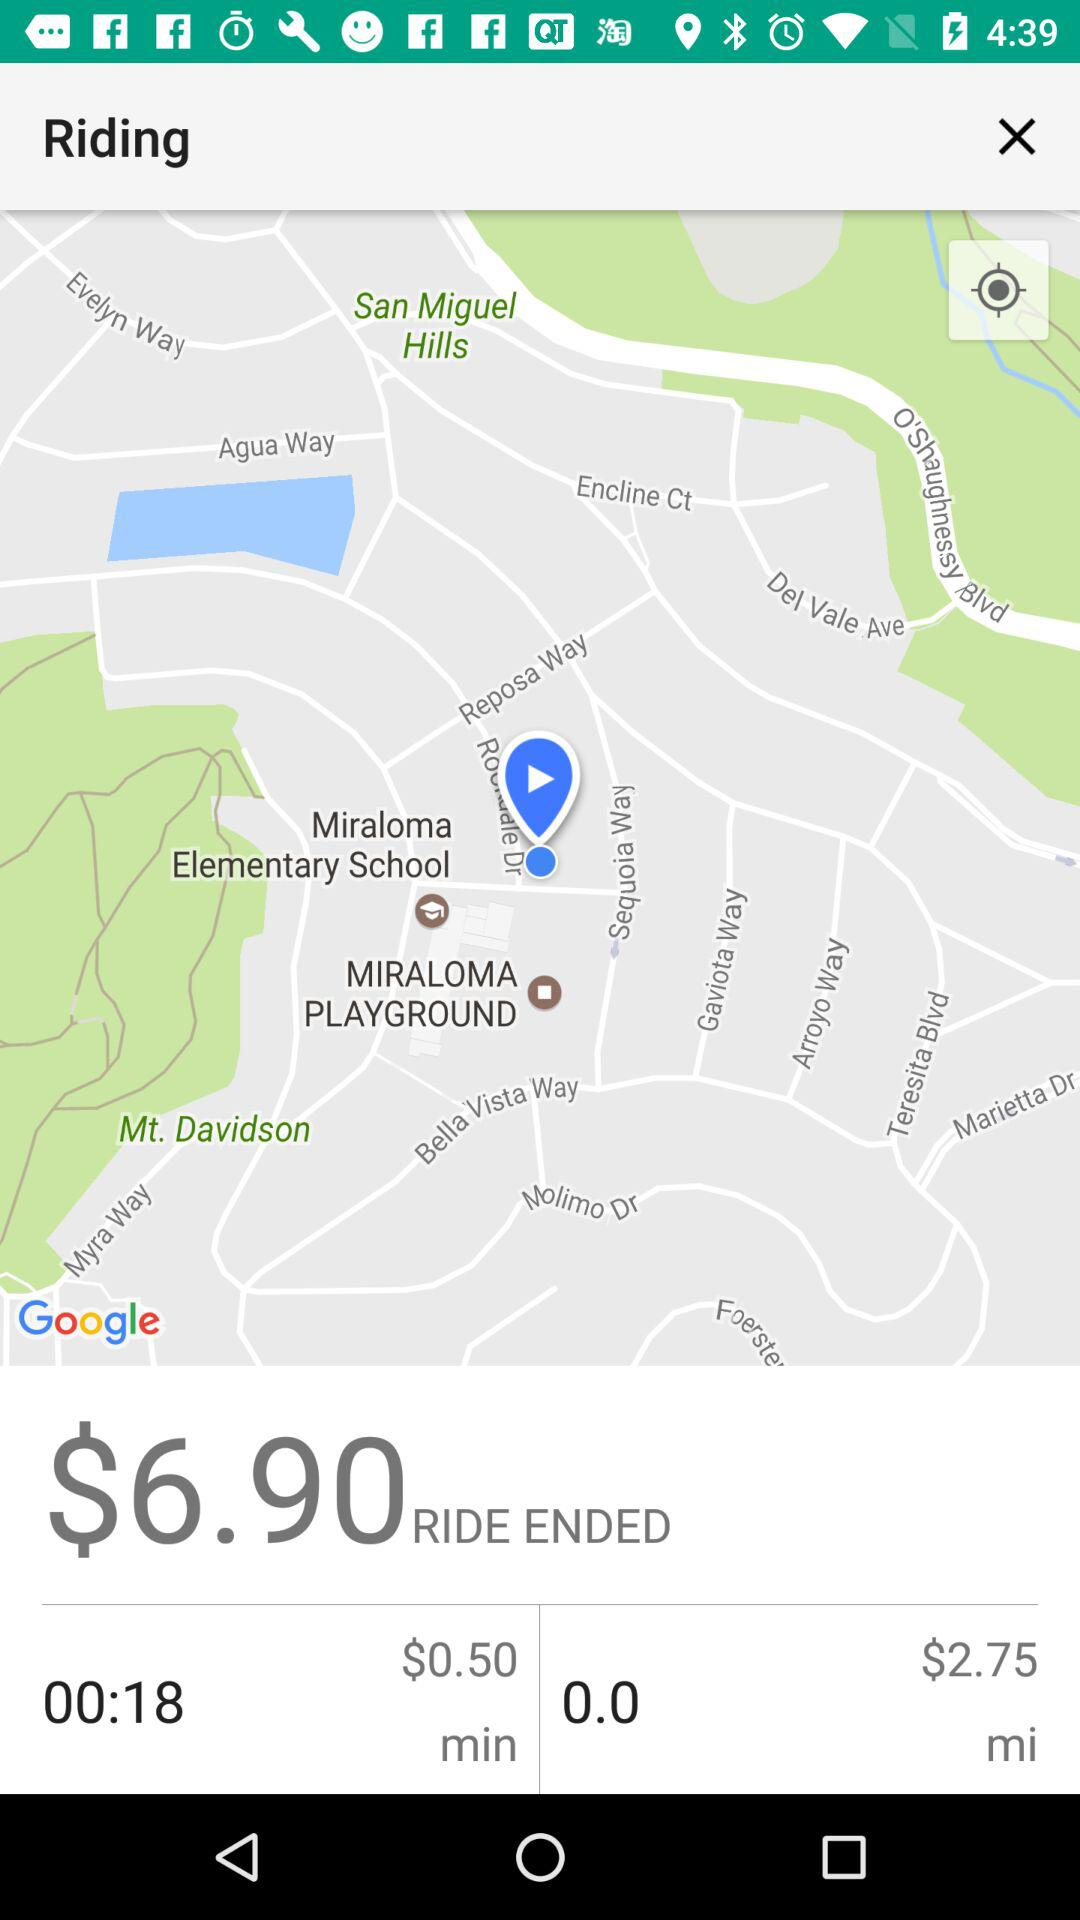What is the duration of the ride? The duration is 18 seconds. 